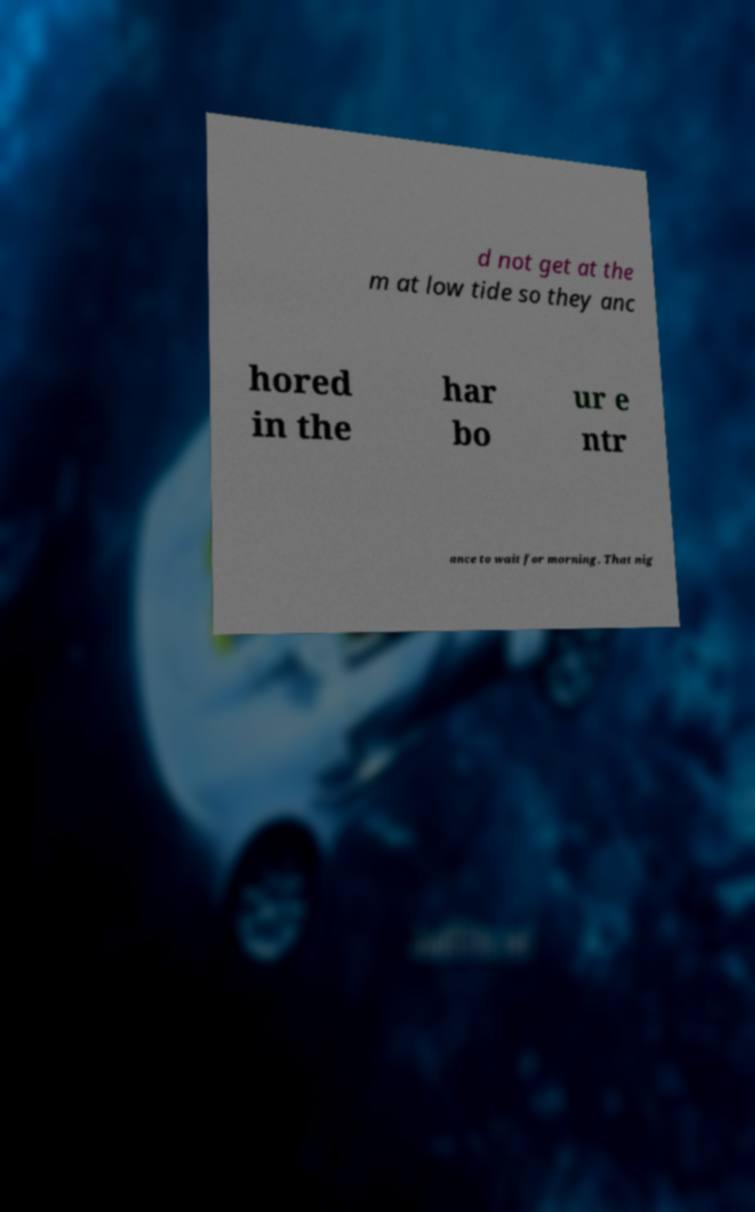Can you accurately transcribe the text from the provided image for me? d not get at the m at low tide so they anc hored in the har bo ur e ntr ance to wait for morning. That nig 